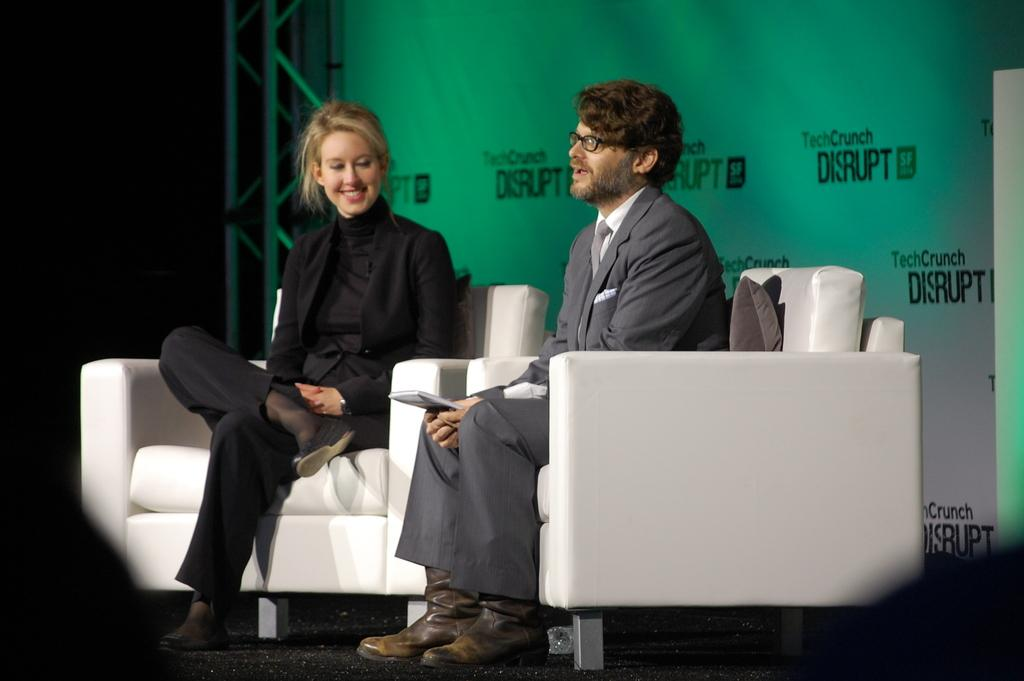Who are the people in the image? There is a man and a woman in the image. What are the man and woman doing in the image? Both the man and woman are sitting on chairs. What is the man holding in the image? The man is holding a book. What can be seen in the background of the image? There is a banner visible in the background. What type of zipper is visible on the cloth in the image? There is no zipper or cloth present in the image. 